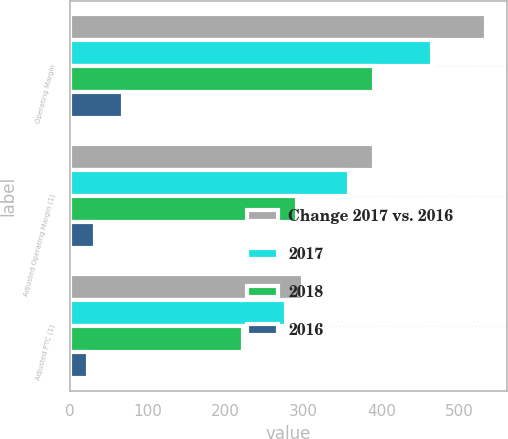Convert chart to OTSL. <chart><loc_0><loc_0><loc_500><loc_500><stacked_bar_chart><ecel><fcel>Operating Margin<fcel>Adjusted Operating Margin (1)<fcel>Adjusted PTC (1)<nl><fcel>Change 2017 vs. 2016<fcel>534<fcel>391<fcel>300<nl><fcel>2017<fcel>465<fcel>358<fcel>277<nl><fcel>2018<fcel>390<fcel>292<fcel>222<nl><fcel>2016<fcel>69<fcel>33<fcel>23<nl></chart> 